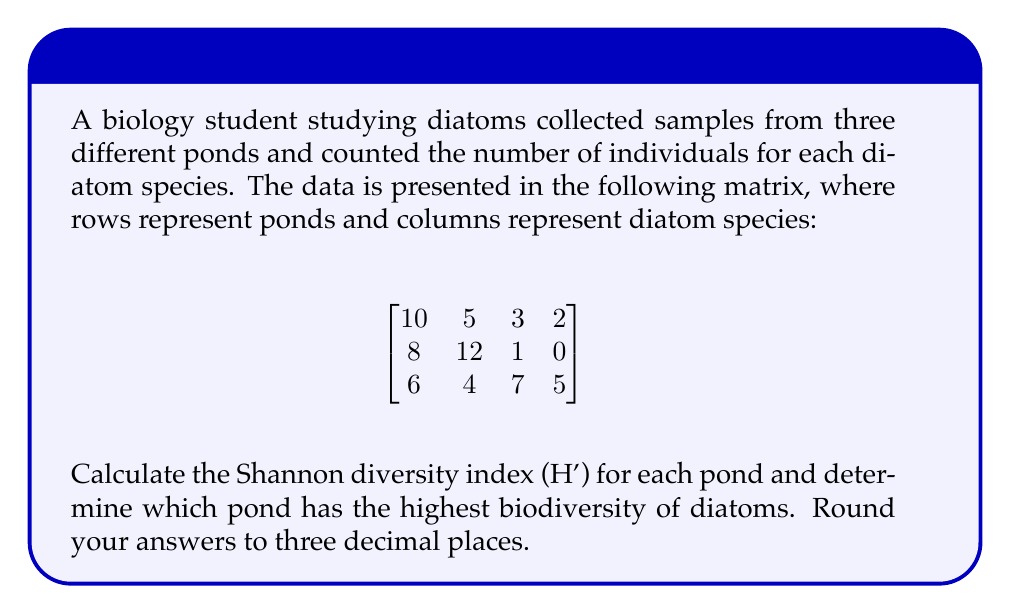Provide a solution to this math problem. To solve this problem, we'll follow these steps:

1) The Shannon diversity index (H') is calculated using the formula:

   $$H' = -\sum_{i=1}^{R} p_i \ln(p_i)$$

   where $R$ is the number of species, and $p_i$ is the proportion of individuals belonging to the i-th species.

2) For each pond, we need to:
   a) Calculate the total number of individuals
   b) Calculate the proportion of each species
   c) Apply the formula

3) Pond 1:
   Total individuals: 10 + 5 + 3 + 2 = 20
   Proportions: 10/20, 5/20, 3/20, 2/20
   
   $$H'_1 = -(\frac{10}{20}\ln(\frac{10}{20}) + \frac{5}{20}\ln(\frac{5}{20}) + \frac{3}{20}\ln(\frac{3}{20}) + \frac{2}{20}\ln(\frac{2}{20}))$$
   
   $$H'_1 = 1.215$$

4) Pond 2:
   Total individuals: 8 + 12 + 1 + 0 = 21
   Proportions: 8/21, 12/21, 1/21, 0/21 (note: 0 is excluded from calculation)
   
   $$H'_2 = -(\frac{8}{21}\ln(\frac{8}{21}) + \frac{12}{21}\ln(\frac{12}{21}) + \frac{1}{21}\ln(\frac{1}{21}))$$
   
   $$H'_2 = 0.893$$

5) Pond 3:
   Total individuals: 6 + 4 + 7 + 5 = 22
   Proportions: 6/22, 4/22, 7/22, 5/22
   
   $$H'_3 = -(\frac{6}{22}\ln(\frac{6}{22}) + \frac{4}{22}\ln(\frac{4}{22}) + \frac{7}{22}\ln(\frac{7}{22}) + \frac{5}{22}\ln(\frac{5}{22}))$$
   
   $$H'_3 = 1.360$$

6) Comparing the H' values, we can see that Pond 3 has the highest Shannon diversity index, indicating the highest biodiversity of diatoms.
Answer: Pond 1: H' = 1.215
Pond 2: H' = 0.893
Pond 3: H' = 1.360
Highest biodiversity: Pond 3 